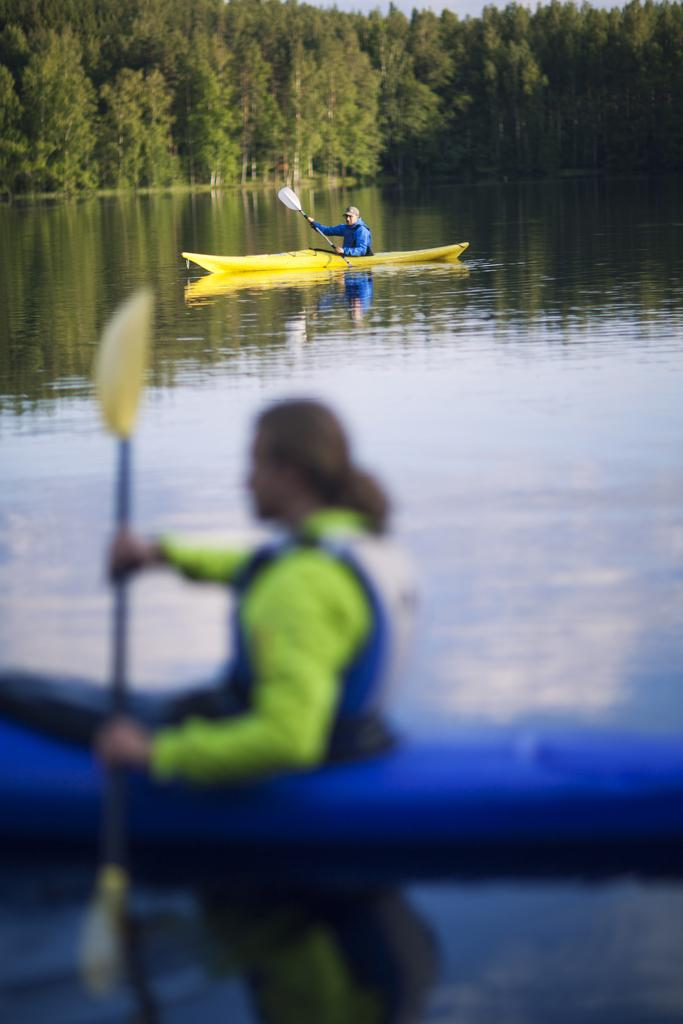How many people are in the image? There are two people in the image. What are the people doing in the image? The people are rowing in the water. What tools are they using to row? The people are using paddles. What can be seen in the background of the image? There are trees and the sky visible in the background of the image. What is the temper of the water in the image? The provided facts do not mention the temper of the water, so it cannot be determined from the image. 